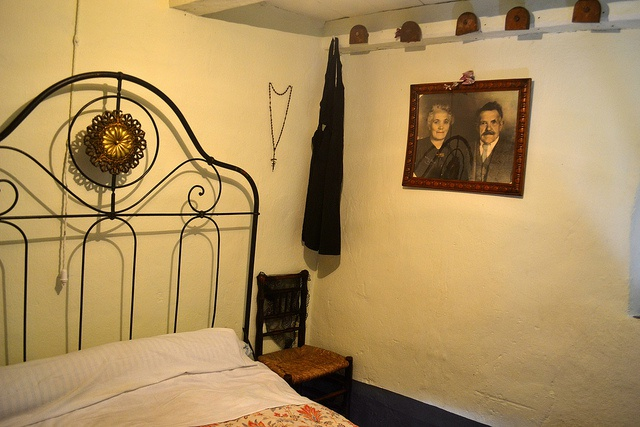Describe the objects in this image and their specific colors. I can see bed in tan and gray tones and chair in tan, black, maroon, and brown tones in this image. 